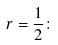<formula> <loc_0><loc_0><loc_500><loc_500>r = \frac { 1 } { 2 } \colon</formula> 